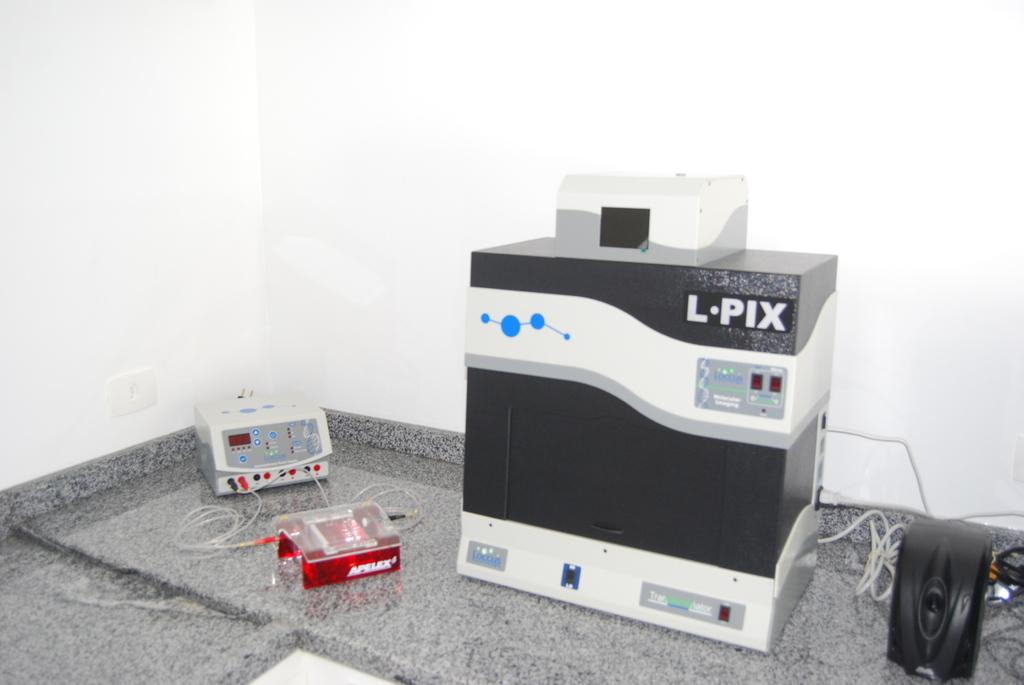What object can be seen in the image that is typically used for storage or organization? There is a box in the image. What small animal is present in the image? There is a mouse in the image. What type of material is visible in the image that is often used for transmitting electricity or data? There are wires in the image. How many electronic devices can be seen in the image? There are two electronic devices in the image. Where are the electronic devices located in the image? The electronic devices are placed on the floor. What can be seen in the background of the image? There is a wall visible in the background of the image. What is the opinion of the mouse regarding the trade of electronic devices in the image? There is no indication of the mouse's opinion or any trade of electronic devices in the image. 